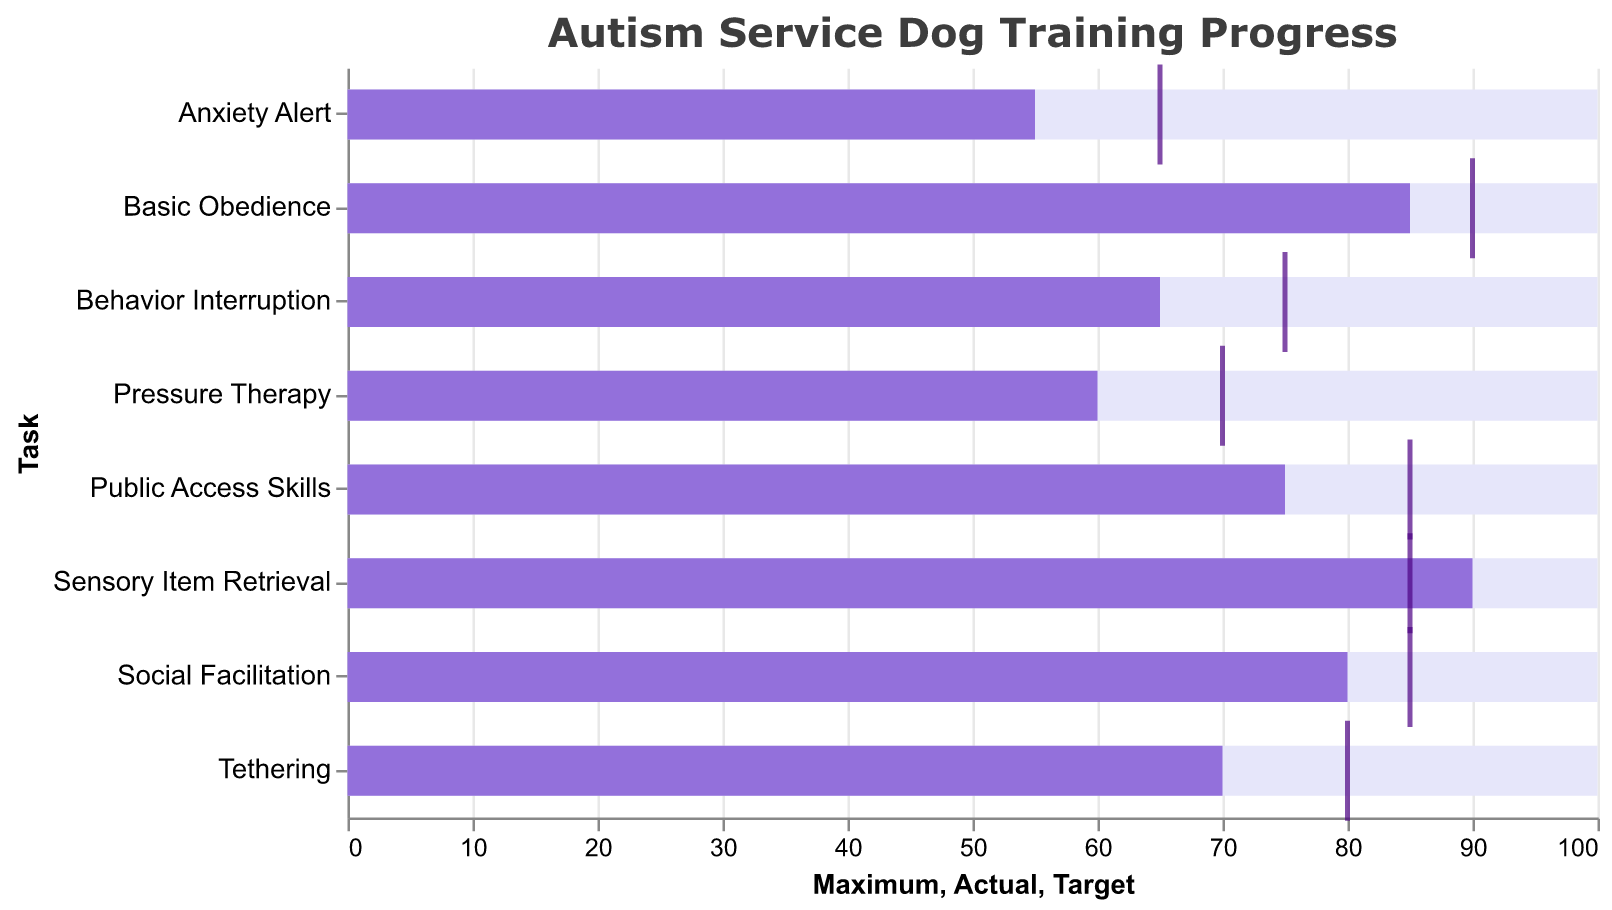What is the target value for 'Basic Obedience'? The figure shows a tick mark representing the target values for each task. For 'Basic Obedience', the tick mark is located at the 90 position on the x-axis.
Answer: 90 Which task has the highest actual progress? By observing the bars that show actual progress for each task, 'Sensory Item Retrieval' has the highest actual progress, which is at 90%.
Answer: Sensory Item Retrieval How many tasks have an actual value greater than 75? Check the actual values (purple bars) for each task and count the number of tasks where the bars extend beyond the 75 mark on the x-axis. 'Basic Obedience', 'Social Facilitation', 'Public Access Skills', and 'Sensory Item Retrieval' meet this criterion.
Answer: 4 What is the median target value across all tasks? Sort target values: 65, 70, 75, 80, 85, 85, 85, 90. There are 8 tasks, so the median is the average of the 4th and 5th values: (80 + 85) / 2 = 82.5
Answer: 82.5 Which task exceeds its target value? Identify tasks where the actual progress bar (purple) extends beyond the target tick mark (dark purple). 'Sensory Item Retrieval' has an actual value of 90, which exceeds its target value of 85.
Answer: Sensory Item Retrieval What is the difference between the maximum and actual value for 'Pressure Therapy'? The maximum value for 'Pressure Therapy' is 100, and the actual value is 60. The difference is 100 - 60 = 40.
Answer: 40 